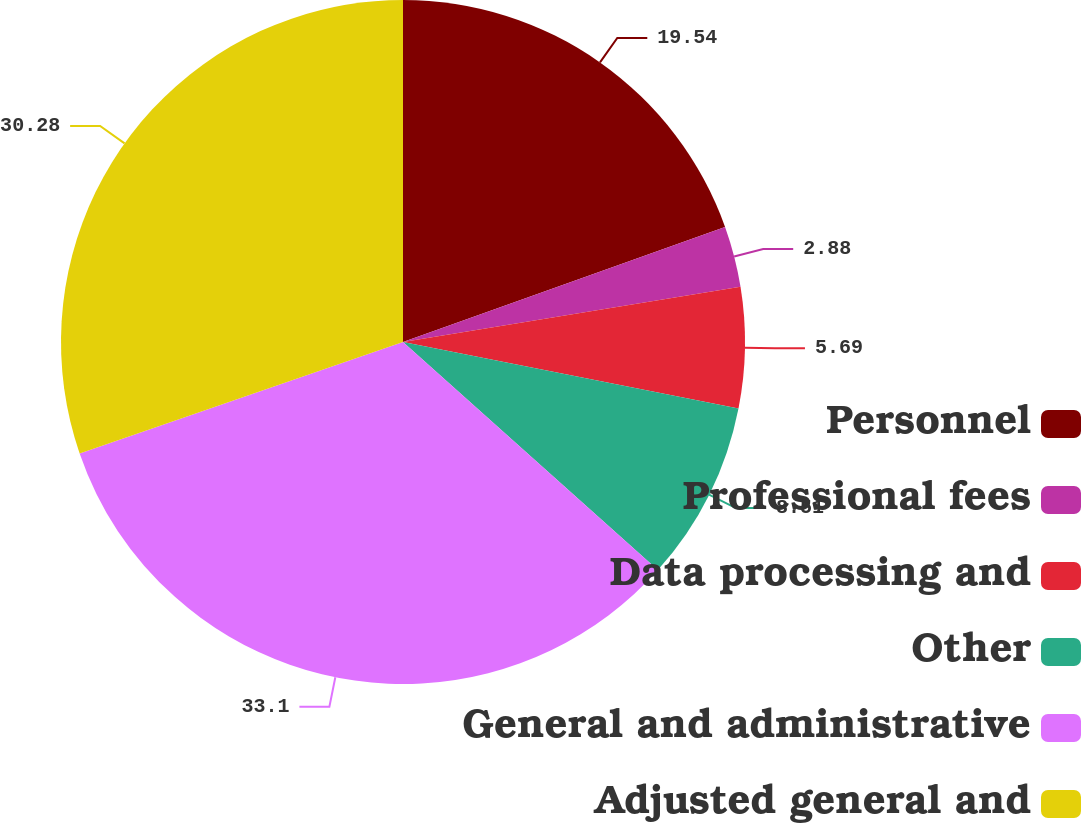Convert chart. <chart><loc_0><loc_0><loc_500><loc_500><pie_chart><fcel>Personnel<fcel>Professional fees<fcel>Data processing and<fcel>Other<fcel>General and administrative<fcel>Adjusted general and<nl><fcel>19.54%<fcel>2.88%<fcel>5.69%<fcel>8.51%<fcel>33.1%<fcel>30.28%<nl></chart> 